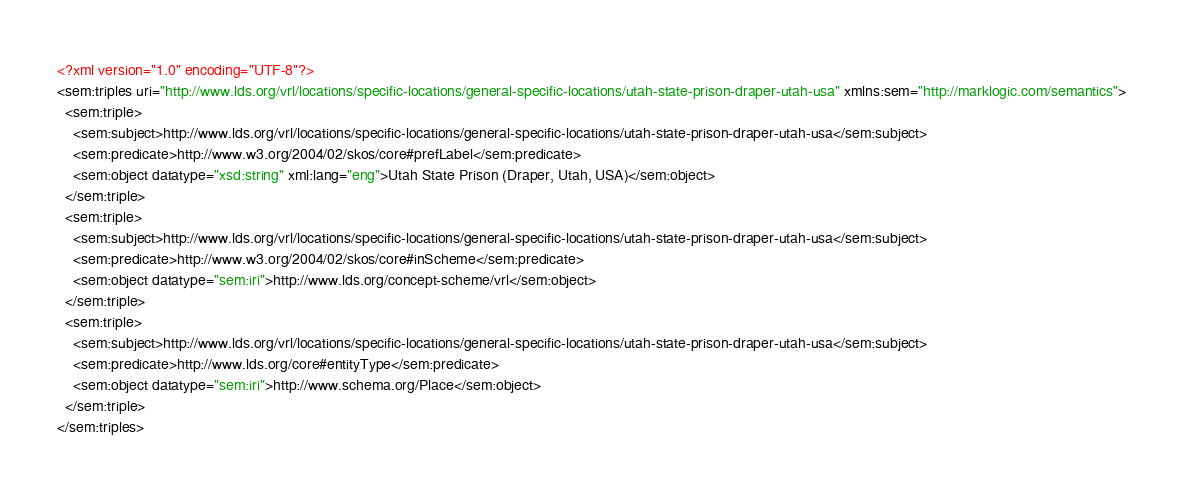Convert code to text. <code><loc_0><loc_0><loc_500><loc_500><_XML_><?xml version="1.0" encoding="UTF-8"?>
<sem:triples uri="http://www.lds.org/vrl/locations/specific-locations/general-specific-locations/utah-state-prison-draper-utah-usa" xmlns:sem="http://marklogic.com/semantics">
  <sem:triple>
    <sem:subject>http://www.lds.org/vrl/locations/specific-locations/general-specific-locations/utah-state-prison-draper-utah-usa</sem:subject>
    <sem:predicate>http://www.w3.org/2004/02/skos/core#prefLabel</sem:predicate>
    <sem:object datatype="xsd:string" xml:lang="eng">Utah State Prison (Draper, Utah, USA)</sem:object>
  </sem:triple>
  <sem:triple>
    <sem:subject>http://www.lds.org/vrl/locations/specific-locations/general-specific-locations/utah-state-prison-draper-utah-usa</sem:subject>
    <sem:predicate>http://www.w3.org/2004/02/skos/core#inScheme</sem:predicate>
    <sem:object datatype="sem:iri">http://www.lds.org/concept-scheme/vrl</sem:object>
  </sem:triple>
  <sem:triple>
    <sem:subject>http://www.lds.org/vrl/locations/specific-locations/general-specific-locations/utah-state-prison-draper-utah-usa</sem:subject>
    <sem:predicate>http://www.lds.org/core#entityType</sem:predicate>
    <sem:object datatype="sem:iri">http://www.schema.org/Place</sem:object>
  </sem:triple>
</sem:triples>
</code> 